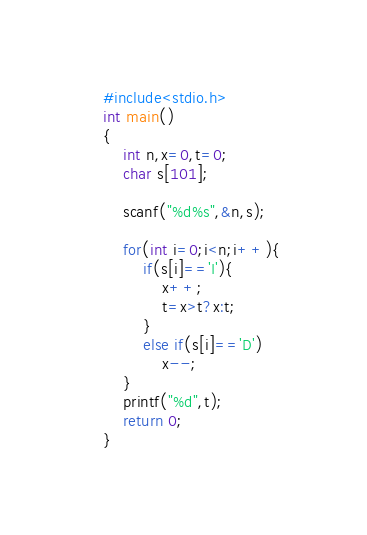Convert code to text. <code><loc_0><loc_0><loc_500><loc_500><_C_>#include<stdio.h>
int main()
{
	int n,x=0,t=0;
	char s[101];

	scanf("%d%s",&n,s);

	for(int i=0;i<n;i++){
		if(s[i]=='I'){
			x++;
			t=x>t?x:t;
		}
		else if(s[i]=='D')
			x--;
	}
	printf("%d",t);
	return 0;
}</code> 